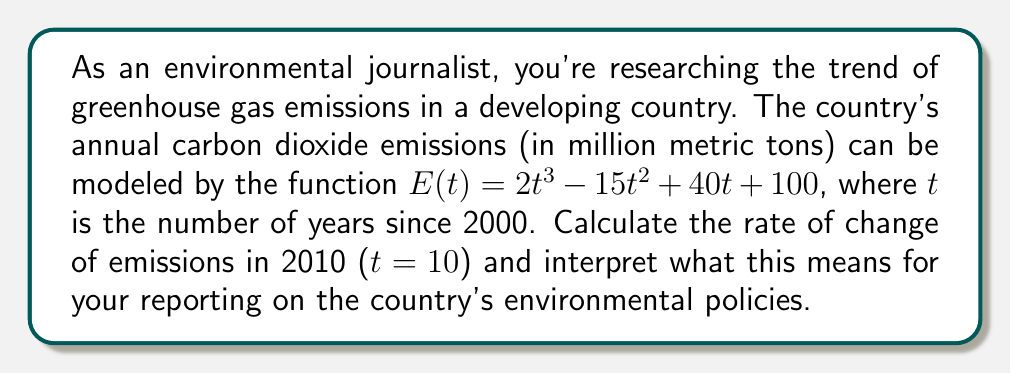Can you solve this math problem? To solve this problem, we need to follow these steps:

1) The rate of change of emissions is given by the derivative of the function $E(t)$. Let's call this $E'(t)$.

2) To find $E'(t)$, we differentiate $E(t)$ with respect to $t$:

   $$E'(t) = \frac{d}{dt}(2t^3 - 15t^2 + 40t + 100)$$

   $$E'(t) = 6t^2 - 30t + 40$$

3) Now, we need to calculate the rate of change in 2010, which is when $t = 10$:

   $$E'(10) = 6(10)^2 - 30(10) + 40$$
   
   $$E'(10) = 600 - 300 + 40$$
   
   $$E'(10) = 340$$

4) Interpretation: The rate of change of 340 million metric tons per year means that in 2010, the country's carbon dioxide emissions were increasing at a rate of 340 million metric tons each year.

This rapid increase in emissions could be a critical point for your environmental reporting. It suggests that as of 2010, the country's greenhouse gas emissions were rising sharply, which could indicate ineffective environmental policies or rapid industrial growth without sufficient green technology implementation.
Answer: The rate of change of emissions in 2010 is 340 million metric tons per year. 